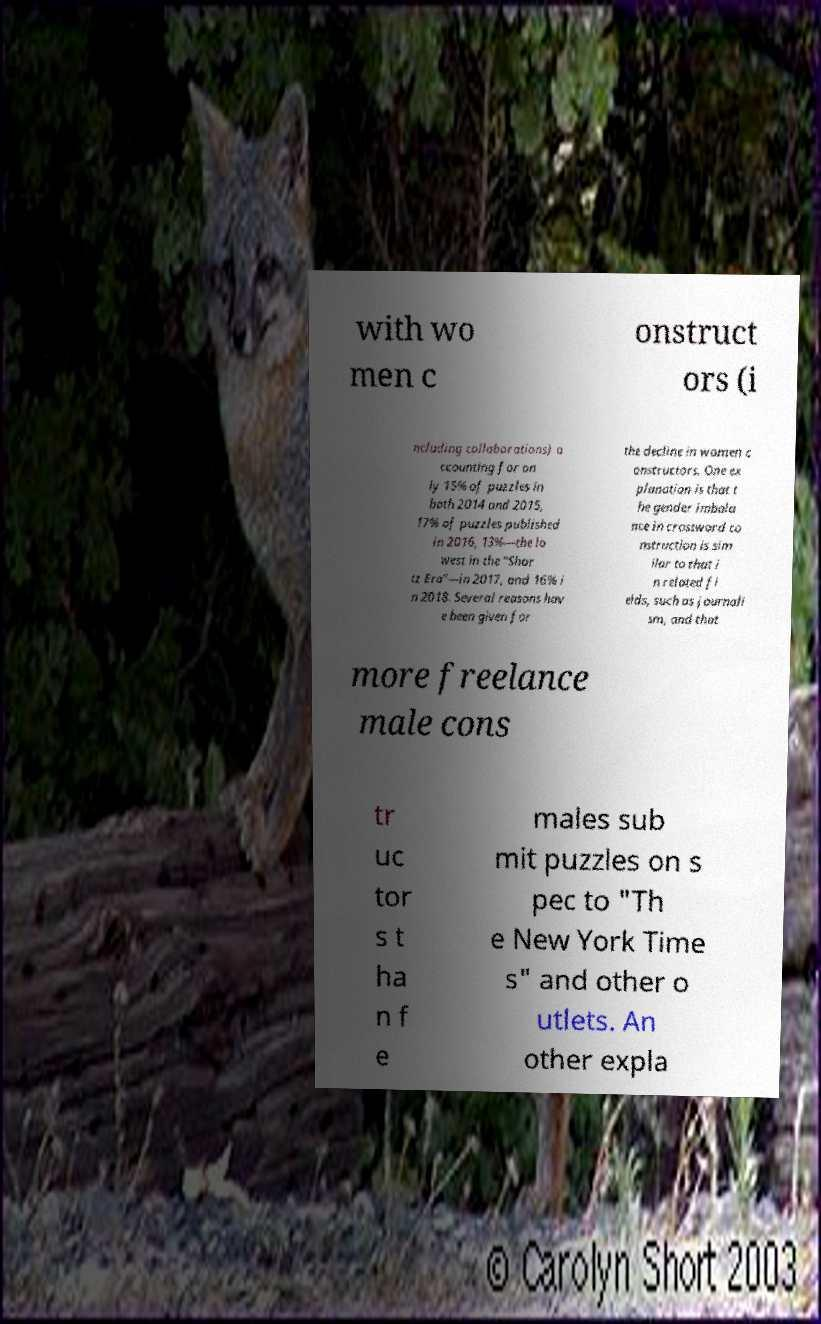Could you extract and type out the text from this image? with wo men c onstruct ors (i ncluding collaborations) a ccounting for on ly 15% of puzzles in both 2014 and 2015, 17% of puzzles published in 2016, 13%—the lo west in the "Shor tz Era"—in 2017, and 16% i n 2018. Several reasons hav e been given for the decline in women c onstructors. One ex planation is that t he gender imbala nce in crossword co nstruction is sim ilar to that i n related fi elds, such as journali sm, and that more freelance male cons tr uc tor s t ha n f e males sub mit puzzles on s pec to "Th e New York Time s" and other o utlets. An other expla 